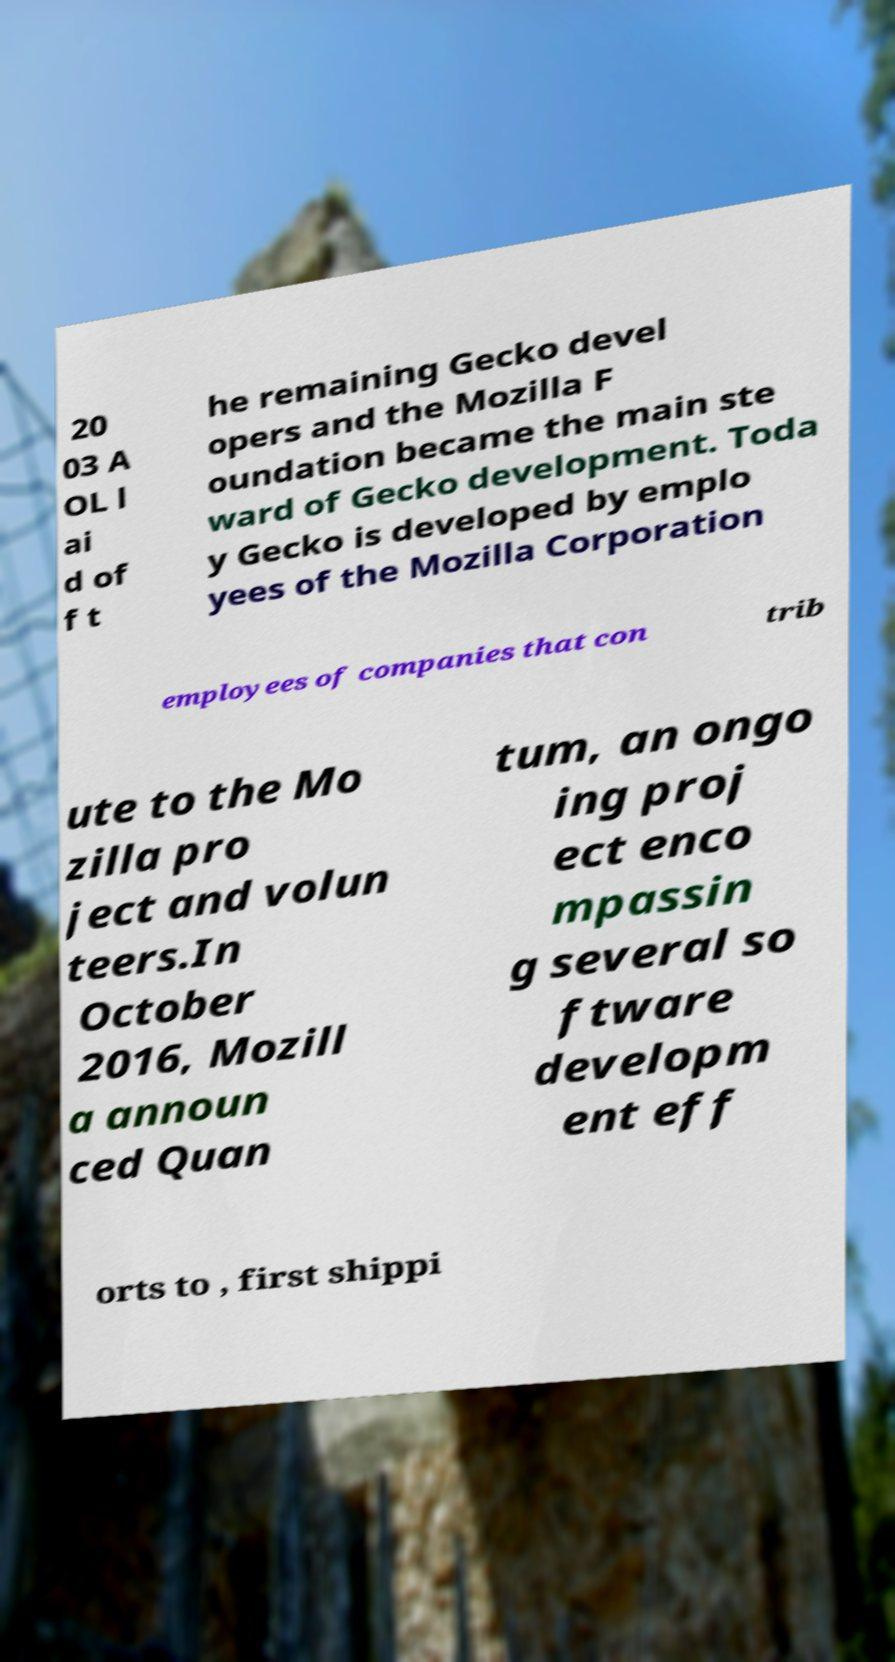I need the written content from this picture converted into text. Can you do that? 20 03 A OL l ai d of f t he remaining Gecko devel opers and the Mozilla F oundation became the main ste ward of Gecko development. Toda y Gecko is developed by emplo yees of the Mozilla Corporation employees of companies that con trib ute to the Mo zilla pro ject and volun teers.In October 2016, Mozill a announ ced Quan tum, an ongo ing proj ect enco mpassin g several so ftware developm ent eff orts to , first shippi 